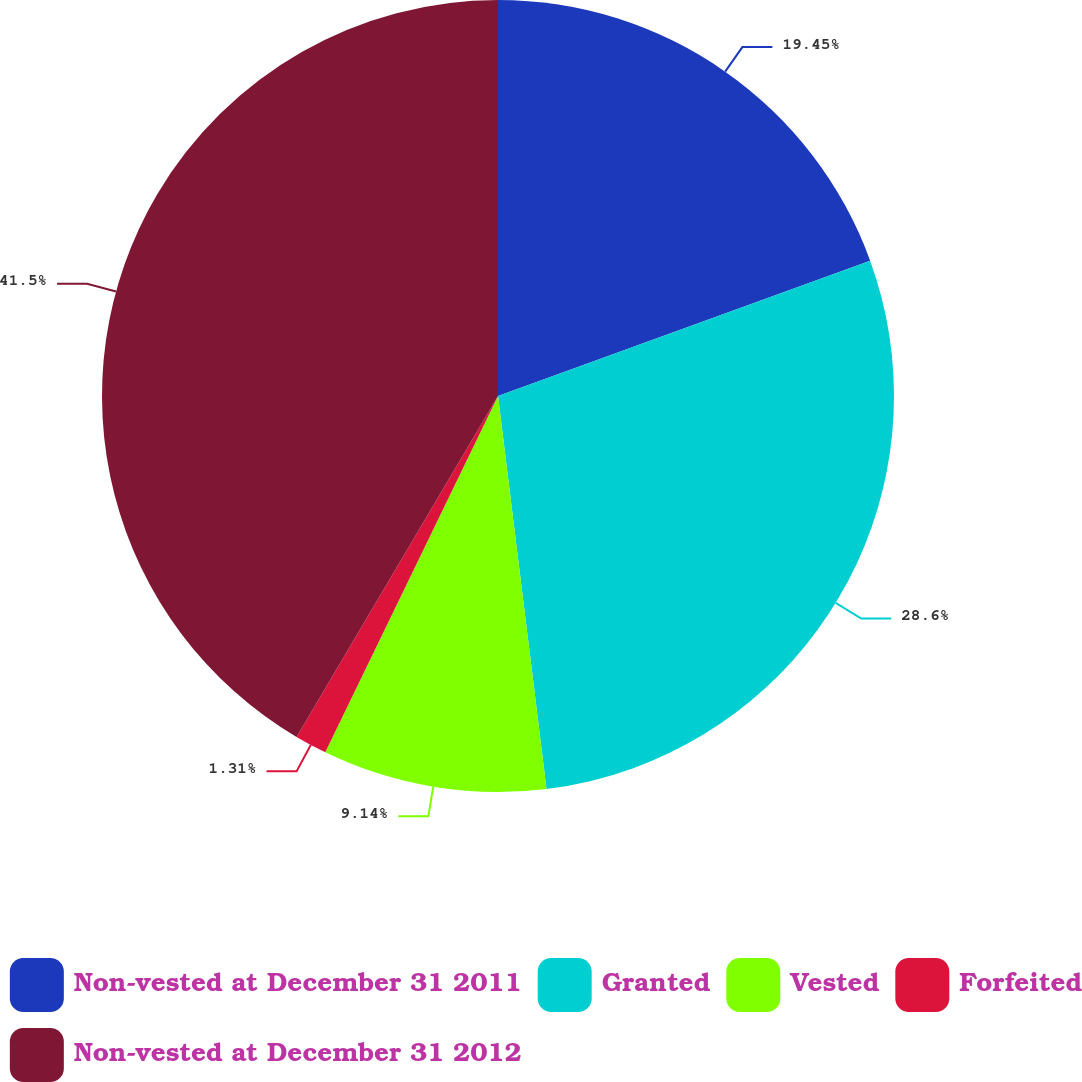<chart> <loc_0><loc_0><loc_500><loc_500><pie_chart><fcel>Non-vested at December 31 2011<fcel>Granted<fcel>Vested<fcel>Forfeited<fcel>Non-vested at December 31 2012<nl><fcel>19.45%<fcel>28.6%<fcel>9.14%<fcel>1.31%<fcel>41.51%<nl></chart> 